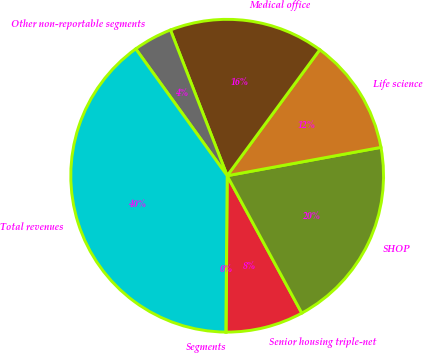Convert chart. <chart><loc_0><loc_0><loc_500><loc_500><pie_chart><fcel>Segments<fcel>Senior housing triple-net<fcel>SHOP<fcel>Life science<fcel>Medical office<fcel>Other non-reportable segments<fcel>Total revenues<nl><fcel>0.04%<fcel>8.02%<fcel>19.98%<fcel>12.01%<fcel>15.99%<fcel>4.03%<fcel>39.92%<nl></chart> 